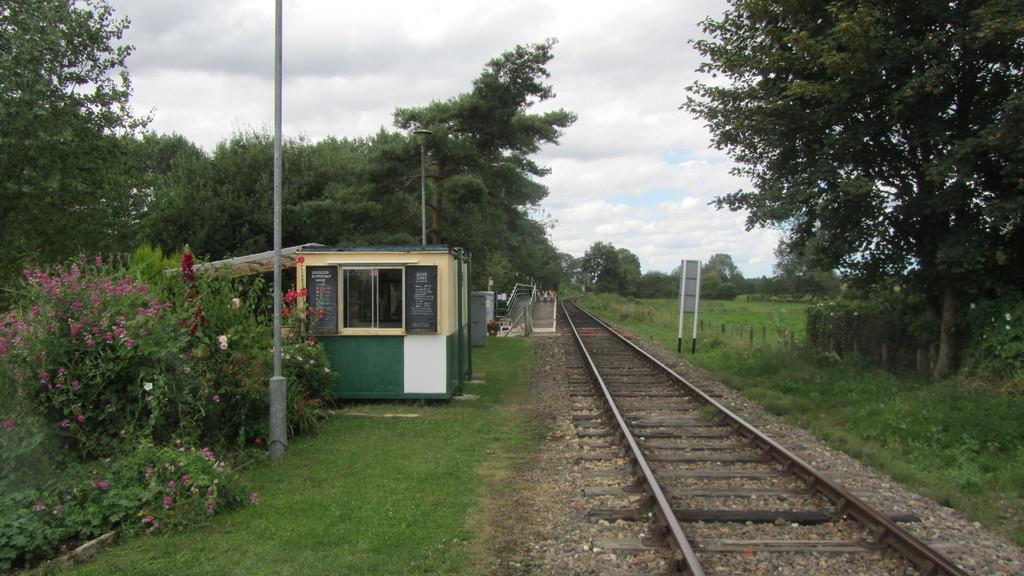How would you summarize this image in a sentence or two? In this picture we can see view of the railway track in the forest. Beside there is a green and yellow color shade tent. Beside there are many trees and on the right side we can see the caution board. 